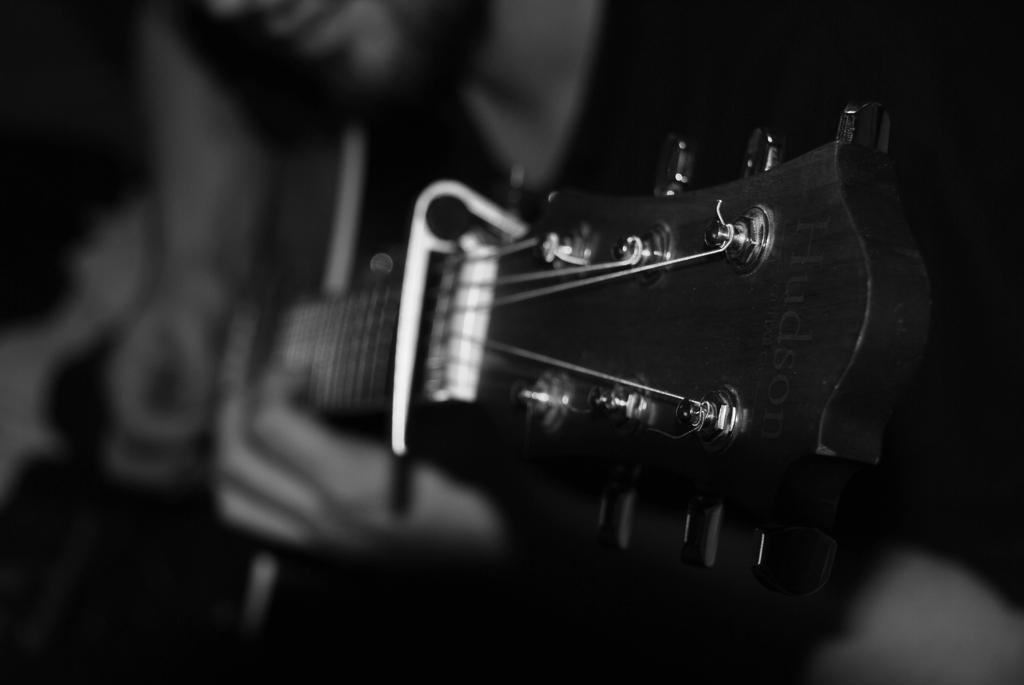What is the main subject of the image? There is a man in the image. What is the man doing in the image? The man is playing a guitar. What type of whip is the man using while playing the guitar in the image? There is no whip present in the image; the man is only playing a guitar. What brand of jeans is the man wearing in the image? The image does not provide information about the man's jeans, so it cannot be determined from the image. 